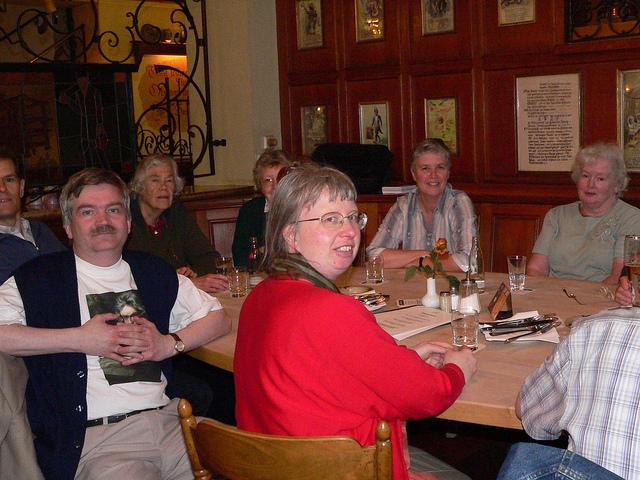How many pictures are on the wall?
Give a very brief answer. 9. What color sweater does the woman on the right have on?
Keep it brief. Red. Do the people have food?
Keep it brief. No. What kind of beverage is on the table?
Be succinct. Water. How many people are wearing glasses?
Write a very short answer. 2. What kind of animal is on the wall?
Short answer required. None. How many men are sitting at the table?
Write a very short answer. 3. Red or white wine?
Answer briefly. White. 